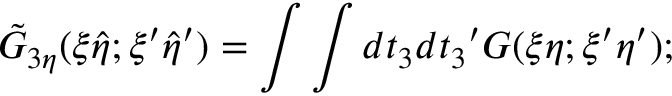Convert formula to latex. <formula><loc_0><loc_0><loc_500><loc_500>{ \tilde { G } } _ { 3 \eta } ( \xi { \hat { \eta } } ; { \xi } ^ { \prime } { \hat { \eta } } ^ { \prime } ) = \int \int d t _ { 3 } d { t _ { 3 } } ^ { \prime } G ( \xi \eta ; { \xi } ^ { \prime } { \eta } ^ { \prime } ) ;</formula> 